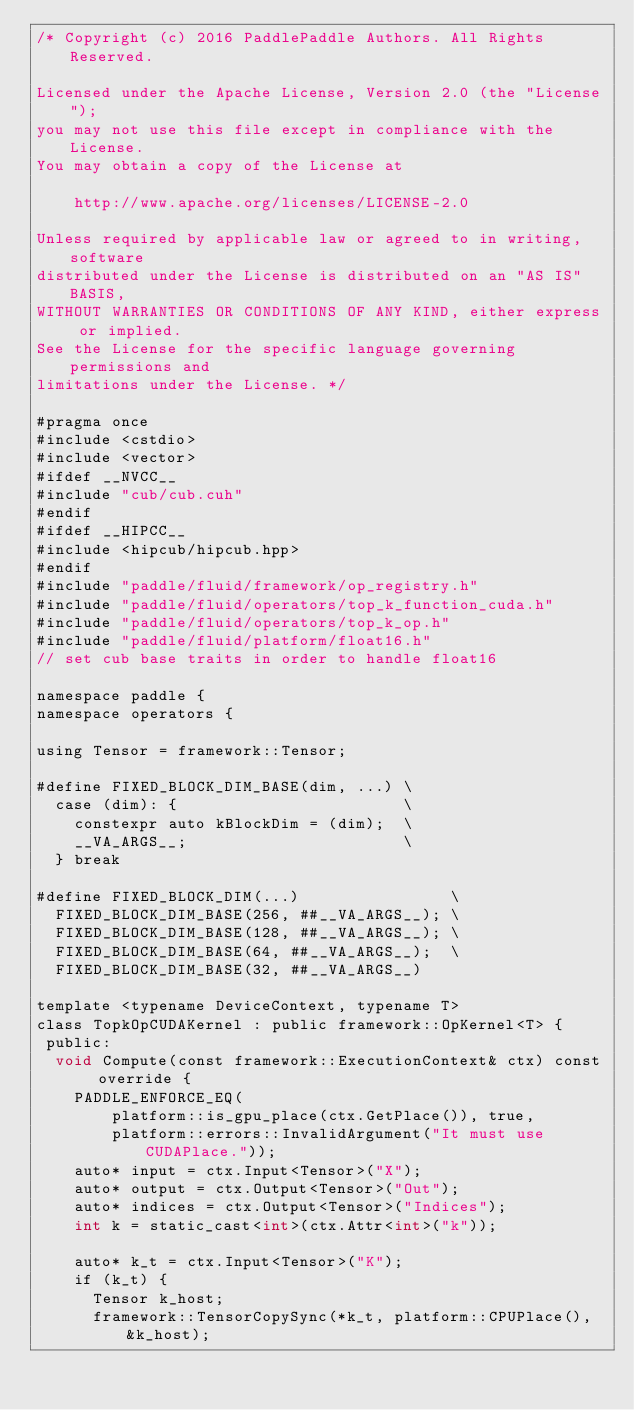Convert code to text. <code><loc_0><loc_0><loc_500><loc_500><_Cuda_>/* Copyright (c) 2016 PaddlePaddle Authors. All Rights Reserved.

Licensed under the Apache License, Version 2.0 (the "License");
you may not use this file except in compliance with the License.
You may obtain a copy of the License at

    http://www.apache.org/licenses/LICENSE-2.0

Unless required by applicable law or agreed to in writing, software
distributed under the License is distributed on an "AS IS" BASIS,
WITHOUT WARRANTIES OR CONDITIONS OF ANY KIND, either express or implied.
See the License for the specific language governing permissions and
limitations under the License. */

#pragma once
#include <cstdio>
#include <vector>
#ifdef __NVCC__
#include "cub/cub.cuh"
#endif
#ifdef __HIPCC__
#include <hipcub/hipcub.hpp>
#endif
#include "paddle/fluid/framework/op_registry.h"
#include "paddle/fluid/operators/top_k_function_cuda.h"
#include "paddle/fluid/operators/top_k_op.h"
#include "paddle/fluid/platform/float16.h"
// set cub base traits in order to handle float16

namespace paddle {
namespace operators {

using Tensor = framework::Tensor;

#define FIXED_BLOCK_DIM_BASE(dim, ...) \
  case (dim): {                        \
    constexpr auto kBlockDim = (dim);  \
    __VA_ARGS__;                       \
  } break

#define FIXED_BLOCK_DIM(...)                \
  FIXED_BLOCK_DIM_BASE(256, ##__VA_ARGS__); \
  FIXED_BLOCK_DIM_BASE(128, ##__VA_ARGS__); \
  FIXED_BLOCK_DIM_BASE(64, ##__VA_ARGS__);  \
  FIXED_BLOCK_DIM_BASE(32, ##__VA_ARGS__)

template <typename DeviceContext, typename T>
class TopkOpCUDAKernel : public framework::OpKernel<T> {
 public:
  void Compute(const framework::ExecutionContext& ctx) const override {
    PADDLE_ENFORCE_EQ(
        platform::is_gpu_place(ctx.GetPlace()), true,
        platform::errors::InvalidArgument("It must use CUDAPlace."));
    auto* input = ctx.Input<Tensor>("X");
    auto* output = ctx.Output<Tensor>("Out");
    auto* indices = ctx.Output<Tensor>("Indices");
    int k = static_cast<int>(ctx.Attr<int>("k"));

    auto* k_t = ctx.Input<Tensor>("K");
    if (k_t) {
      Tensor k_host;
      framework::TensorCopySync(*k_t, platform::CPUPlace(), &k_host);</code> 